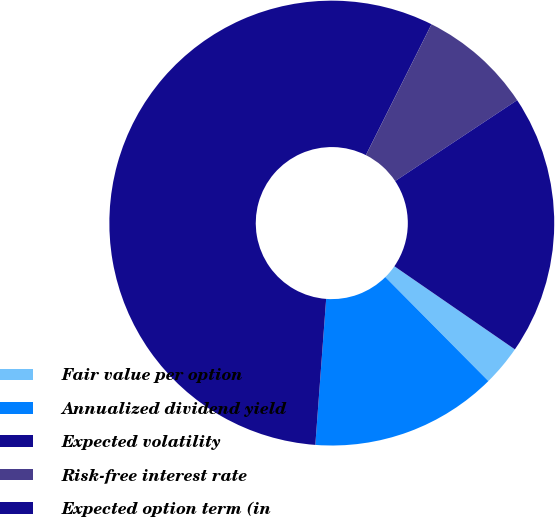Convert chart. <chart><loc_0><loc_0><loc_500><loc_500><pie_chart><fcel>Fair value per option<fcel>Annualized dividend yield<fcel>Expected volatility<fcel>Risk-free interest rate<fcel>Expected option term (in<nl><fcel>2.96%<fcel>13.61%<fcel>56.22%<fcel>8.28%<fcel>18.93%<nl></chart> 